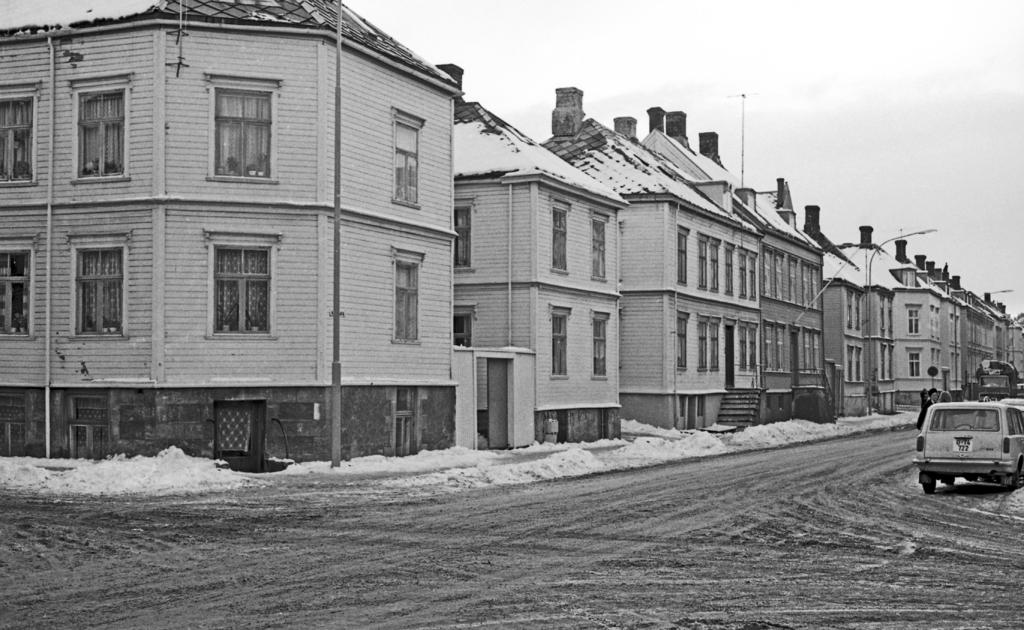What types of objects are present in the image? There are vehicles, light poles, and buildings in the image. Can you describe the color scheme of the image? The image is in black and white. What type of feeling can be seen on the faces of the people in the image? There are no people present in the image, so it is not possible to determine their feelings. What time of day is depicted in the image? The provided facts do not mention the time of day, so it cannot be determined from the image. 